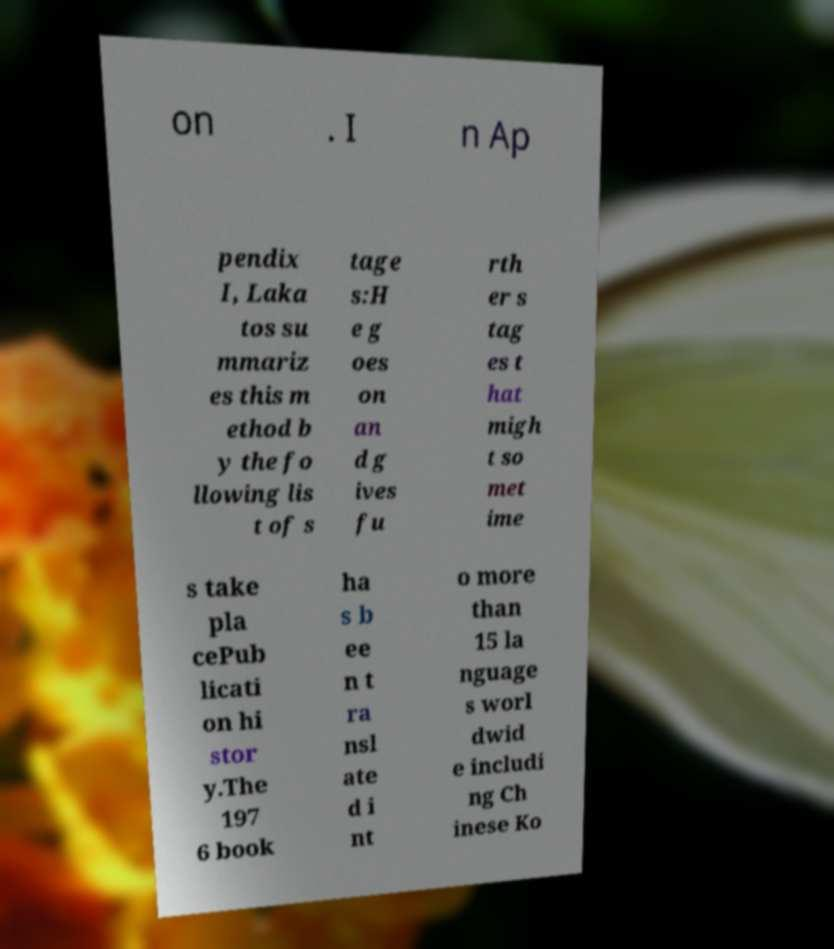Please read and relay the text visible in this image. What does it say? on . I n Ap pendix I, Laka tos su mmariz es this m ethod b y the fo llowing lis t of s tage s:H e g oes on an d g ives fu rth er s tag es t hat migh t so met ime s take pla cePub licati on hi stor y.The 197 6 book ha s b ee n t ra nsl ate d i nt o more than 15 la nguage s worl dwid e includi ng Ch inese Ko 